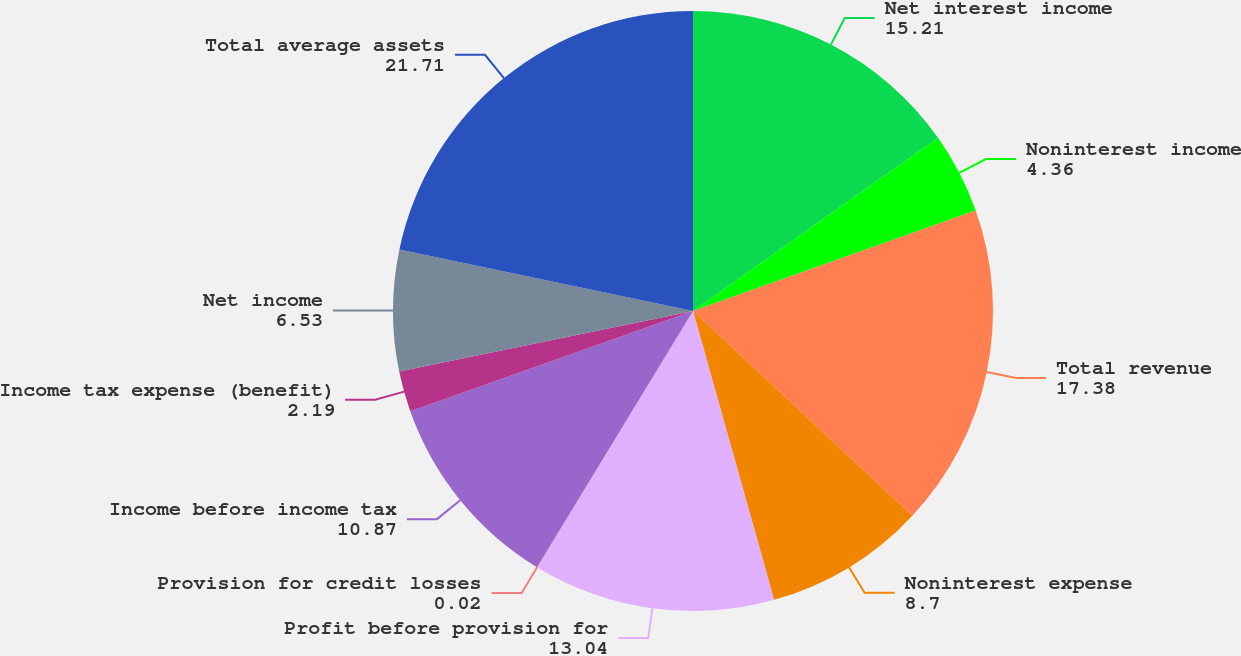Convert chart. <chart><loc_0><loc_0><loc_500><loc_500><pie_chart><fcel>Net interest income<fcel>Noninterest income<fcel>Total revenue<fcel>Noninterest expense<fcel>Profit before provision for<fcel>Provision for credit losses<fcel>Income before income tax<fcel>Income tax expense (benefit)<fcel>Net income<fcel>Total average assets<nl><fcel>15.21%<fcel>4.36%<fcel>17.38%<fcel>8.7%<fcel>13.04%<fcel>0.02%<fcel>10.87%<fcel>2.19%<fcel>6.53%<fcel>21.71%<nl></chart> 